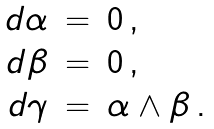Convert formula to latex. <formula><loc_0><loc_0><loc_500><loc_500>\begin{array} { r c l } d \alpha & = & 0 \, , \\ d \beta & = & 0 \, , \\ d \gamma & = & \alpha \wedge \beta \, . \end{array}</formula> 